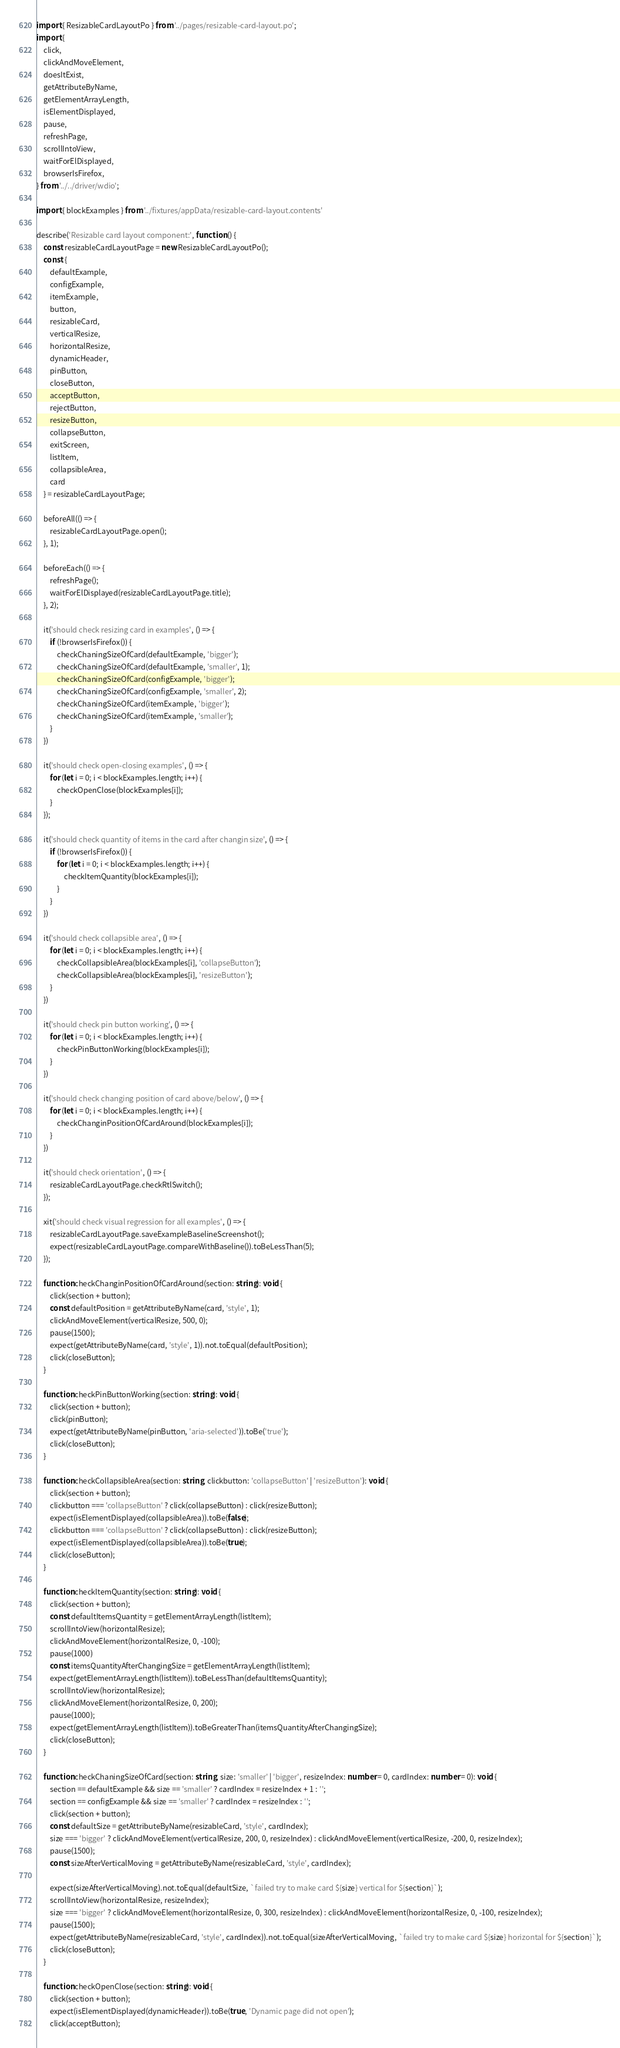Convert code to text. <code><loc_0><loc_0><loc_500><loc_500><_TypeScript_>import { ResizableCardLayoutPo } from '../pages/resizable-card-layout.po';
import {
    click,
    clickAndMoveElement,
    doesItExist,
    getAttributeByName,
    getElementArrayLength,
    isElementDisplayed,
    pause,
    refreshPage,
    scrollIntoView,
    waitForElDisplayed,
    browserIsFirefox,
} from '../../driver/wdio';

import { blockExamples } from '../fixtures/appData/resizable-card-layout.contents'

describe('Resizable card layout component:', function () {
    const resizableCardLayoutPage = new ResizableCardLayoutPo();
    const {
        defaultExample,
        configExample,
        itemExample,
        button,
        resizableCard,
        verticalResize,
        horizontalResize,
        dynamicHeader,
        pinButton,
        closeButton,
        acceptButton,
        rejectButton,
        resizeButton,
        collapseButton,
        exitScreen,
        listItem,
        collapsibleArea,
        card
    } = resizableCardLayoutPage;

    beforeAll(() => {
        resizableCardLayoutPage.open();
    }, 1);

    beforeEach(() => {
        refreshPage();
        waitForElDisplayed(resizableCardLayoutPage.title);
    }, 2);

    it('should check resizing card in examples', () => {
        if (!browserIsFirefox()) {
            checkChaningSizeOfCard(defaultExample, 'bigger');
            checkChaningSizeOfCard(defaultExample, 'smaller', 1);
            checkChaningSizeOfCard(configExample, 'bigger');
            checkChaningSizeOfCard(configExample, 'smaller', 2);
            checkChaningSizeOfCard(itemExample, 'bigger');
            checkChaningSizeOfCard(itemExample, 'smaller');
        }
    })

    it('should check open-closing examples', () => {
        for (let i = 0; i < blockExamples.length; i++) {
            checkOpenClose(blockExamples[i]);
        }
    });

    it('should check quantity of items in the card after changin size', () => {
        if (!browserIsFirefox()) {
            for (let i = 0; i < blockExamples.length; i++) {
                checkItemQuantity(blockExamples[i]);
            }
        }
    })

    it('should check collapsible area', () => {
        for (let i = 0; i < blockExamples.length; i++) {
            checkCollapsibleArea(blockExamples[i], 'collapseButton');
            checkCollapsibleArea(blockExamples[i], 'resizeButton');
        }
    })

    it('should check pin button working', () => {
        for (let i = 0; i < blockExamples.length; i++) {
            checkPinButtonWorking(blockExamples[i]);
        }
    })

    it('should check changing position of card above/below', () => {
        for (let i = 0; i < blockExamples.length; i++) {
            checkChanginPositionOfCardAround(blockExamples[i]);
        }
    })

    it('should check orientation', () => {
        resizableCardLayoutPage.checkRtlSwitch();
    });

    xit('should check visual regression for all examples', () => {
        resizableCardLayoutPage.saveExampleBaselineScreenshot();
        expect(resizableCardLayoutPage.compareWithBaseline()).toBeLessThan(5);
    });

    function checkChanginPositionOfCardAround(section: string): void {
        click(section + button);
        const defaultPosition = getAttributeByName(card, 'style', 1);
        clickAndMoveElement(verticalResize, 500, 0);
        pause(1500);
        expect(getAttributeByName(card, 'style', 1)).not.toEqual(defaultPosition);
        click(closeButton);
    }

    function checkPinButtonWorking(section: string): void {
        click(section + button);
        click(pinButton);
        expect(getAttributeByName(pinButton, 'aria-selected')).toBe('true');
        click(closeButton);
    }

    function checkCollapsibleArea(section: string, clickbutton: 'collapseButton' | 'resizeButton'): void {
        click(section + button);
        clickbutton === 'collapseButton' ? click(collapseButton) : click(resizeButton);
        expect(isElementDisplayed(collapsibleArea)).toBe(false);
        clickbutton === 'collapseButton' ? click(collapseButton) : click(resizeButton);
        expect(isElementDisplayed(collapsibleArea)).toBe(true);
        click(closeButton);
    }

    function checkItemQuantity(section: string): void {
        click(section + button);
        const defaultItemsQuantity = getElementArrayLength(listItem);
        scrollIntoView(horizontalResize);
        clickAndMoveElement(horizontalResize, 0, -100);
        pause(1000)
        const itemsQuantityAfterChangingSize = getElementArrayLength(listItem);
        expect(getElementArrayLength(listItem)).toBeLessThan(defaultItemsQuantity);
        scrollIntoView(horizontalResize);
        clickAndMoveElement(horizontalResize, 0, 200);
        pause(1000);
        expect(getElementArrayLength(listItem)).toBeGreaterThan(itemsQuantityAfterChangingSize);
        click(closeButton);
    }

    function checkChaningSizeOfCard(section: string, size: 'smaller' | 'bigger', resizeIndex: number = 0, cardIndex: number = 0): void {
        section == defaultExample && size == 'smaller' ? cardIndex = resizeIndex + 1 : '';
        section == configExample && size == 'smaller' ? cardIndex = resizeIndex : '';
        click(section + button);
        const defaultSize = getAttributeByName(resizableCard, 'style', cardIndex);
        size === 'bigger' ? clickAndMoveElement(verticalResize, 200, 0, resizeIndex) : clickAndMoveElement(verticalResize, -200, 0, resizeIndex);
        pause(1500);
        const sizeAfterVerticalMoving = getAttributeByName(resizableCard, 'style', cardIndex);

        expect(sizeAfterVerticalMoving).not.toEqual(defaultSize, `failed try to make card ${size} vertical for ${section}`);
        scrollIntoView(horizontalResize, resizeIndex);
        size === 'bigger' ? clickAndMoveElement(horizontalResize, 0, 300, resizeIndex) : clickAndMoveElement(horizontalResize, 0, -100, resizeIndex);
        pause(1500);
        expect(getAttributeByName(resizableCard, 'style', cardIndex)).not.toEqual(sizeAfterVerticalMoving, `failed try to make card ${size} horizontal for ${section}`);
        click(closeButton);
    }

    function checkOpenClose(section: string): void {
        click(section + button);
        expect(isElementDisplayed(dynamicHeader)).toBe(true, 'Dynamic page did not open');
        click(acceptButton);</code> 